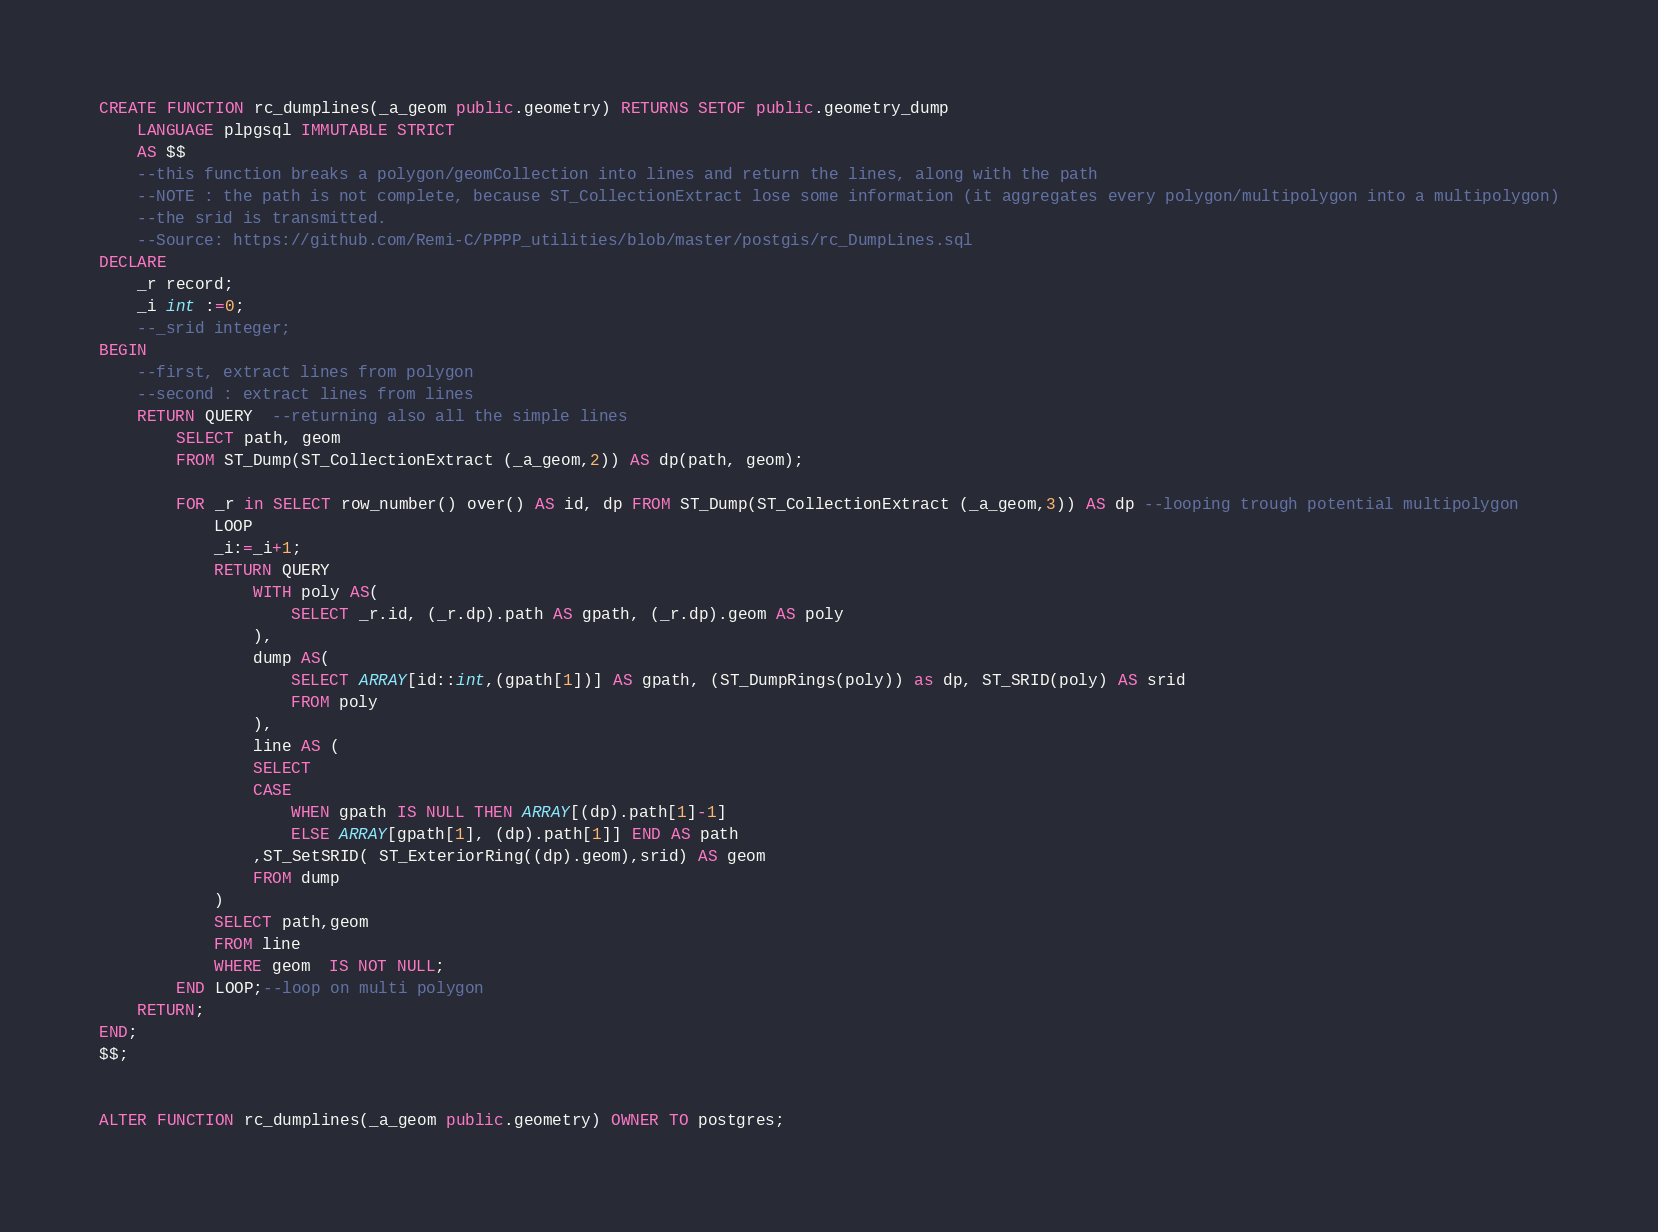<code> <loc_0><loc_0><loc_500><loc_500><_SQL_>CREATE FUNCTION rc_dumplines(_a_geom public.geometry) RETURNS SETOF public.geometry_dump
    LANGUAGE plpgsql IMMUTABLE STRICT
    AS $$
	--this function breaks a polygon/geomCollection into lines and return the lines, along with the path
	--NOTE : the path is not complete, because ST_CollectionExtract lose some information (it aggregates every polygon/multipolygon into a multipolygon)
	--the srid is transmitted.
	--Source: https://github.com/Remi-C/PPPP_utilities/blob/master/postgis/rc_DumpLines.sql
DECLARE
	_r record;
	_i int :=0;
	--_srid integer;
BEGIN
	--first, extract lines from polygon
	--second : extract lines from lines
	RETURN QUERY  --returning also all the simple lines
		SELECT path, geom
		FROM ST_Dump(ST_CollectionExtract (_a_geom,2)) AS dp(path, geom);

		FOR _r in SELECT row_number() over() AS id, dp FROM ST_Dump(ST_CollectionExtract (_a_geom,3)) AS dp --looping trough potential multipolygon
			LOOP
			_i:=_i+1;
			RETURN QUERY 
				WITH poly AS( 
					SELECT _r.id, (_r.dp).path AS gpath, (_r.dp).geom AS poly 
				),
				dump AS(
					SELECT ARRAY[id::int,(gpath[1])] AS gpath, (ST_DumpRings(poly)) as dp, ST_SRID(poly) AS srid
					FROM poly
				),
				line AS (
				SELECT 
				CASE 
					WHEN gpath IS NULL THEN ARRAY[(dp).path[1]-1] 
					ELSE ARRAY[gpath[1], (dp).path[1]] END AS path
				,ST_SetSRID( ST_ExteriorRing((dp).geom),srid) AS geom
				FROM dump
			)
			SELECT path,geom
			FROM line 
			WHERE geom  IS NOT NULL;
		END LOOP;--loop on multi polygon
	RETURN;
END;
$$;


ALTER FUNCTION rc_dumplines(_a_geom public.geometry) OWNER TO postgres;</code> 